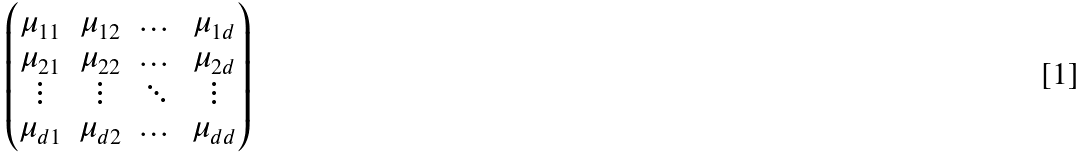<formula> <loc_0><loc_0><loc_500><loc_500>\begin{pmatrix} \mu _ { 1 1 } & \mu _ { 1 2 } & \dots & \mu _ { 1 d } \\ \mu _ { 2 1 } & \mu _ { 2 2 } & \dots & \mu _ { 2 d } \\ \vdots & \vdots & \ddots & \vdots \\ \mu _ { d 1 } & \mu _ { d 2 } & \dots & \mu _ { d d } \end{pmatrix}</formula> 